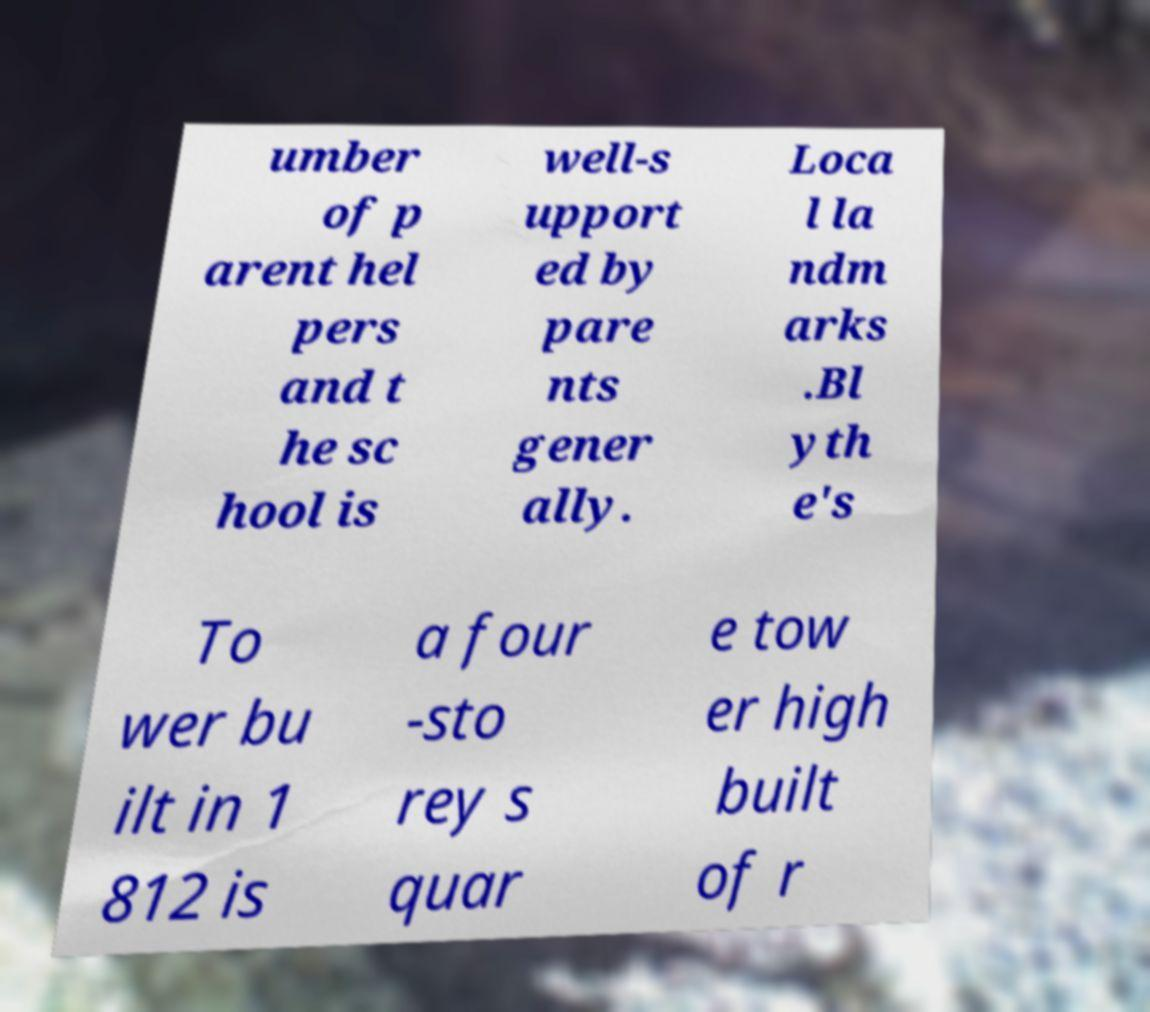Could you extract and type out the text from this image? umber of p arent hel pers and t he sc hool is well-s upport ed by pare nts gener ally. Loca l la ndm arks .Bl yth e's To wer bu ilt in 1 812 is a four -sto rey s quar e tow er high built of r 